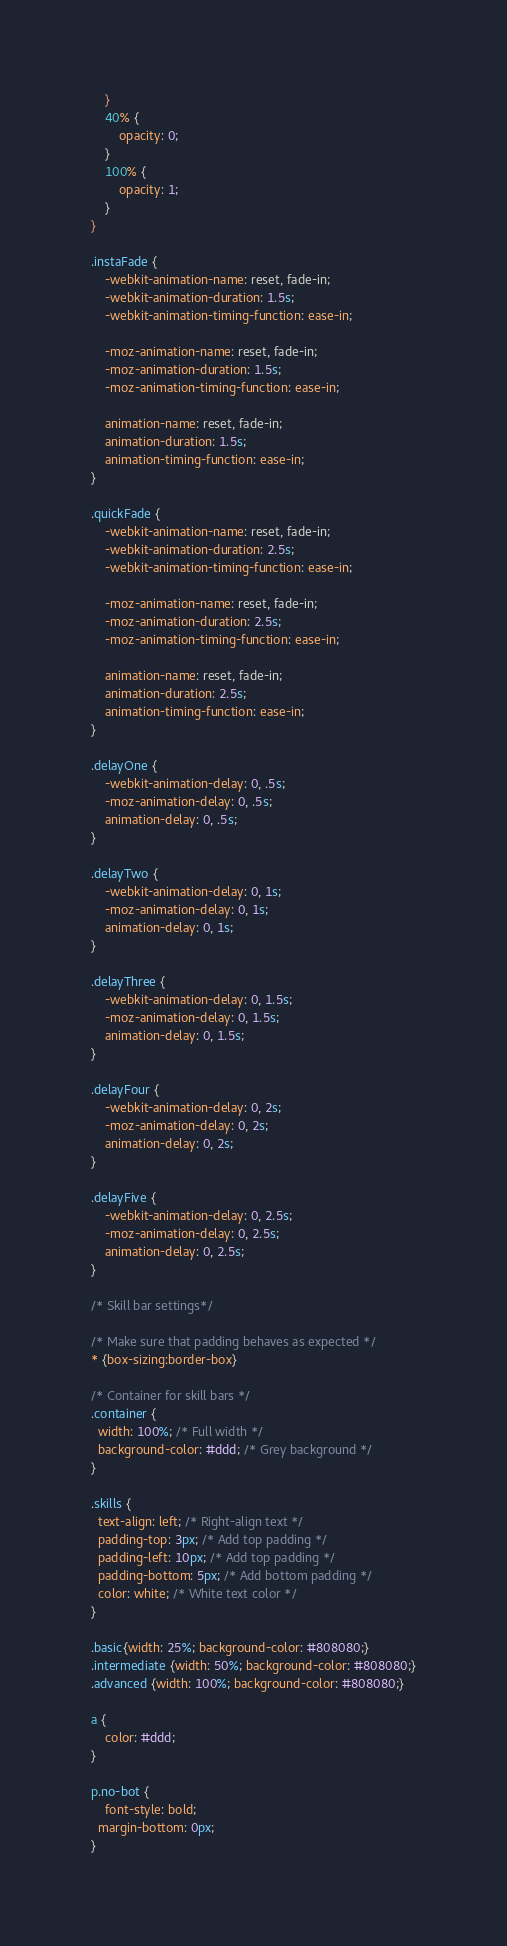<code> <loc_0><loc_0><loc_500><loc_500><_CSS_>	}
	40% {
		opacity: 0;
	}
	100% {
		opacity: 1;
	}
}

.instaFade {
    -webkit-animation-name: reset, fade-in;
    -webkit-animation-duration: 1.5s;
    -webkit-animation-timing-function: ease-in;

	-moz-animation-name: reset, fade-in;
    -moz-animation-duration: 1.5s;
    -moz-animation-timing-function: ease-in;

	animation-name: reset, fade-in;
    animation-duration: 1.5s;
    animation-timing-function: ease-in;
}

.quickFade {
    -webkit-animation-name: reset, fade-in;
    -webkit-animation-duration: 2.5s;
    -webkit-animation-timing-function: ease-in;

	-moz-animation-name: reset, fade-in;
    -moz-animation-duration: 2.5s;
    -moz-animation-timing-function: ease-in;

	animation-name: reset, fade-in;
    animation-duration: 2.5s;
    animation-timing-function: ease-in;
}

.delayOne {
	-webkit-animation-delay: 0, .5s;
	-moz-animation-delay: 0, .5s;
	animation-delay: 0, .5s;
}

.delayTwo {
	-webkit-animation-delay: 0, 1s;
	-moz-animation-delay: 0, 1s;
	animation-delay: 0, 1s;
}

.delayThree {
	-webkit-animation-delay: 0, 1.5s;
	-moz-animation-delay: 0, 1.5s;
	animation-delay: 0, 1.5s;
}

.delayFour {
	-webkit-animation-delay: 0, 2s;
	-moz-animation-delay: 0, 2s;
	animation-delay: 0, 2s;
}

.delayFive {
	-webkit-animation-delay: 0, 2.5s;
	-moz-animation-delay: 0, 2.5s;
	animation-delay: 0, 2.5s;
}

/* Skill bar settings*/

/* Make sure that padding behaves as expected */
* {box-sizing:border-box}

/* Container for skill bars */
.container {
  width: 100%; /* Full width */
  background-color: #ddd; /* Grey background */
}

.skills {
  text-align: left; /* Right-align text */
  padding-top: 3px; /* Add top padding */
  padding-left: 10px; /* Add top padding */
  padding-bottom: 5px; /* Add bottom padding */
  color: white; /* White text color */
}

.basic{width: 25%; background-color: #808080;}
.intermediate {width: 50%; background-color: #808080;}
.advanced {width: 100%; background-color: #808080;}

a {
    color: #ddd;
}

p.no-bot {
	font-style: bold;
  margin-bottom: 0px;
}
</code> 